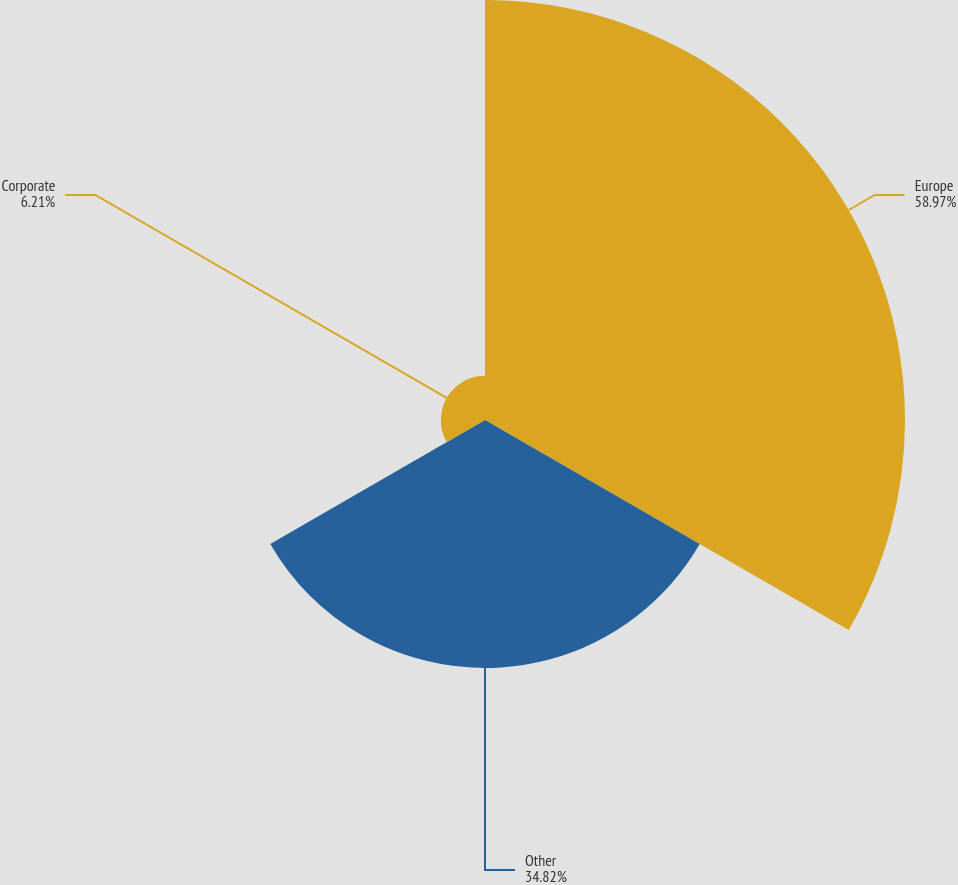<chart> <loc_0><loc_0><loc_500><loc_500><pie_chart><fcel>Europe<fcel>Other<fcel>Corporate<nl><fcel>58.98%<fcel>34.82%<fcel>6.21%<nl></chart> 